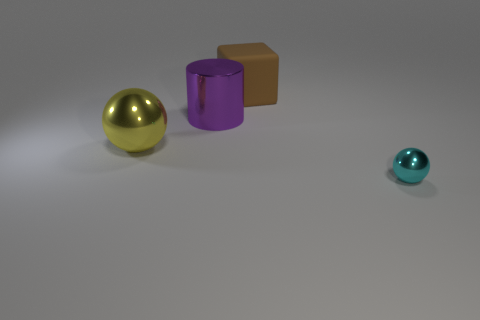Is there any other thing that is the same shape as the brown object?
Your answer should be very brief. No. What size is the yellow object that is the same shape as the tiny cyan object?
Keep it short and to the point. Large. How many other things are there of the same material as the brown object?
Your answer should be compact. 0. What is the material of the block?
Your answer should be compact. Rubber. Is the number of things that are on the right side of the large rubber cube greater than the number of tiny red rubber cylinders?
Offer a terse response. Yes. How many other objects are there of the same color as the cube?
Your answer should be very brief. 0. Is the size of the sphere to the left of the brown cube the same as the large purple thing?
Your answer should be very brief. Yes. Is there a shiny ball of the same size as the metallic cylinder?
Provide a succinct answer. Yes. There is a large shiny thing behind the large yellow metal thing; what is its color?
Provide a succinct answer. Purple. The object that is both in front of the purple metallic thing and left of the small metallic ball has what shape?
Offer a terse response. Sphere. 